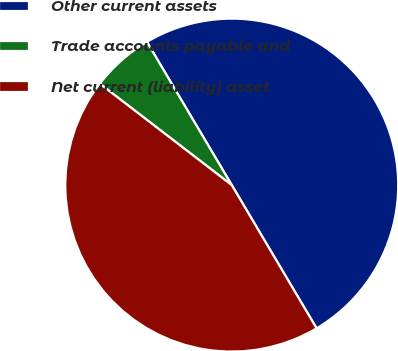Convert chart to OTSL. <chart><loc_0><loc_0><loc_500><loc_500><pie_chart><fcel>Other current assets<fcel>Trade accounts payable and<fcel>Net current (liability) asset<nl><fcel>50.0%<fcel>6.06%<fcel>43.94%<nl></chart> 